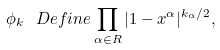Convert formula to latex. <formula><loc_0><loc_0><loc_500><loc_500>\phi _ { k } \ D e f i n e \prod _ { \alpha \in R } | 1 - x ^ { \alpha } | ^ { k _ { \alpha } / 2 } ,</formula> 